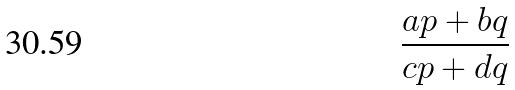Convert formula to latex. <formula><loc_0><loc_0><loc_500><loc_500>\frac { a p + b q } { c p + d q }</formula> 